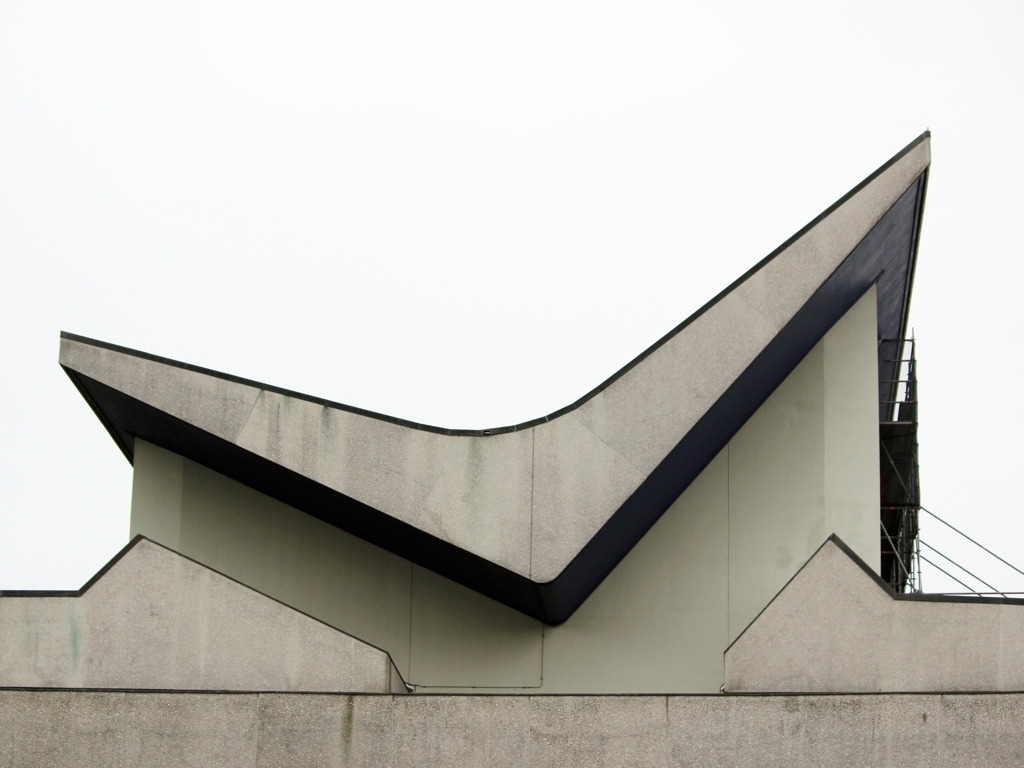What architectural style does this building represent? This building features characteristics of modern architecture, with a minimalist design, clean lines, and geometric shapes creating a distinctive angular profile. 